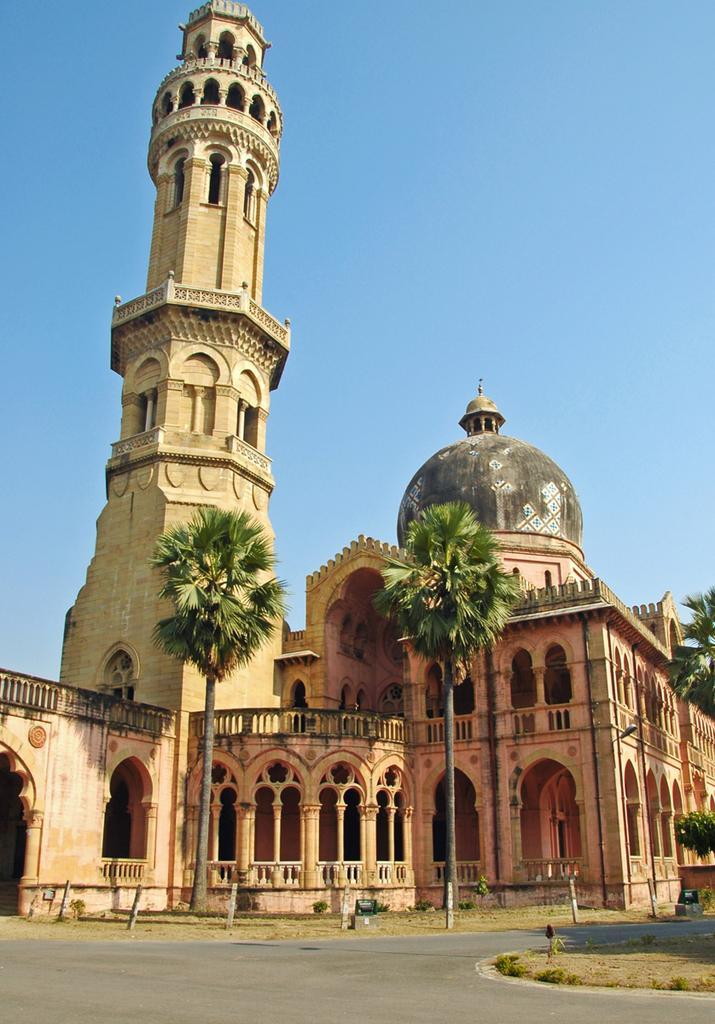Can you describe this image briefly? In this image we can see the Allahabad university building, one light with pole, three pipes attached to the building, some objects on the ground, the road in front of the building, some poles, some trees, plants and grass on the ground. In the background there is the sky. 